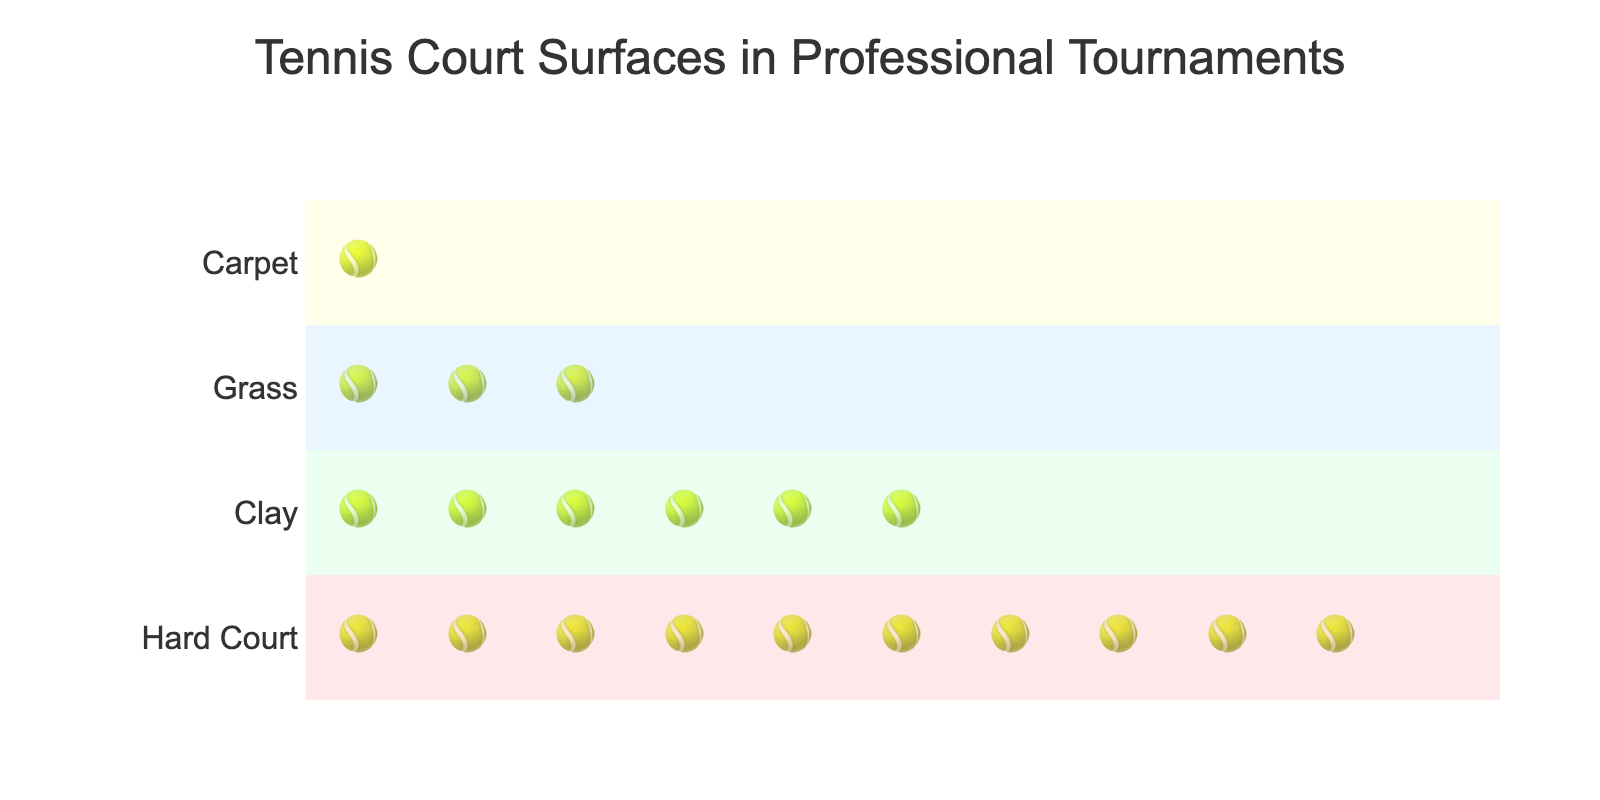What is the title of the figure? The title is usually found at the top of the figure and provides a concise description of what the figure is about. In this case, the title is clearly mentioned: 'Tennis Court Surfaces in Professional Tournaments'.
Answer: Tennis Court Surfaces in Professional Tournaments How many types of tennis court surfaces are presented in the figure? By observing the y-axis labels or the different rows in the figure, we can see four different types of surfaces are listed: Hard Court, Clay, Grass, and Carpet.
Answer: 4 Which surface type has the most professional tournaments according to the figure? The surface type with the most icons (tennis balls) corresponds to the one with the highest count. Hard Court has the most icons, indicating it has the most tournaments.
Answer: Hard Court What surface has the fewest professional tournaments? The surface with the fewest number of icons (tennis balls) is Carpet, as it has the fewest data points mentioned.
Answer: Carpet How many professional tournaments are held on clay courts? The hover information or the counts provided for each surface show that Clay courts have 30 professional tournaments.
Answer: 30 How many more professional tournaments are held on grass courts compared to carpet courts? The number of grass court tournaments is 15, and the number of carpet court tournaments is 5. Therefore, the difference is 15 - 5 = 10.
Answer: 10 What is the combined total of professional tournaments held on Grass and Carpet courts? Adding the number of tournaments held on Grass (15) and Carpet (5) courts gives 15 + 5 = 20.
Answer: 20 Arrange the surface types in descending order based on the number of tournaments held. By looking at the number of tennis ball icons for each surface, we can list them in descending order: Hard Court (50), Clay (30), Grass (15), Carpet (5).
Answer: Hard Court, Clay, Grass, Carpet Which surface type constitutes 30% of the total professional tournaments? The sum of all tournaments is 50 (Hard Court) + 30 (Clay) + 15 (Grass) + 5 (Carpet) = 100. 30% of 100 is 30, which corresponds to Clay courts.
Answer: Clay What is the median count of tournaments across the surface types? Arrange the number of tournaments: 5 (Carpet), 15 (Grass), 30 (Clay), 50 (Hard Court). The median is the average of the two middle values (15 and 30), so (15 + 30) / 2 = 22.5.
Answer: 22.5 